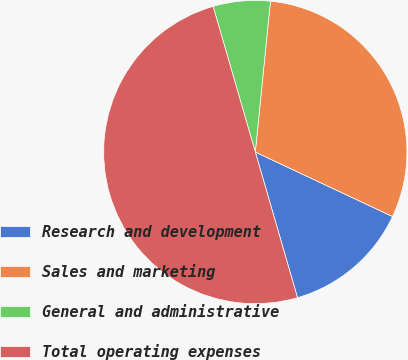<chart> <loc_0><loc_0><loc_500><loc_500><pie_chart><fcel>Research and development<fcel>Sales and marketing<fcel>General and administrative<fcel>Total operating expenses<nl><fcel>13.52%<fcel>30.4%<fcel>6.08%<fcel>50.0%<nl></chart> 